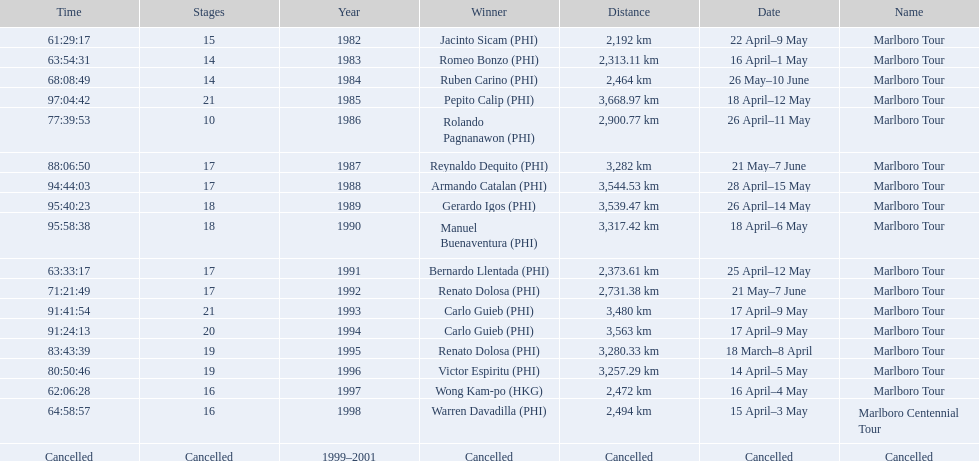Who were all of the winners? Jacinto Sicam (PHI), Romeo Bonzo (PHI), Ruben Carino (PHI), Pepito Calip (PHI), Rolando Pagnanawon (PHI), Reynaldo Dequito (PHI), Armando Catalan (PHI), Gerardo Igos (PHI), Manuel Buenaventura (PHI), Bernardo Llentada (PHI), Renato Dolosa (PHI), Carlo Guieb (PHI), Carlo Guieb (PHI), Renato Dolosa (PHI), Victor Espiritu (PHI), Wong Kam-po (HKG), Warren Davadilla (PHI), Cancelled. When did they compete? 1982, 1983, 1984, 1985, 1986, 1987, 1988, 1989, 1990, 1991, 1992, 1993, 1994, 1995, 1996, 1997, 1998, 1999–2001. What were their finishing times? 61:29:17, 63:54:31, 68:08:49, 97:04:42, 77:39:53, 88:06:50, 94:44:03, 95:40:23, 95:58:38, 63:33:17, 71:21:49, 91:41:54, 91:24:13, 83:43:39, 80:50:46, 62:06:28, 64:58:57, Cancelled. And who won during 1998? Warren Davadilla (PHI). What was his time? 64:58:57. 